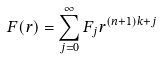Convert formula to latex. <formula><loc_0><loc_0><loc_500><loc_500>F ( r ) = \sum _ { j = 0 } ^ { \infty } F _ { j } r ^ { ( n + 1 ) k + j }</formula> 